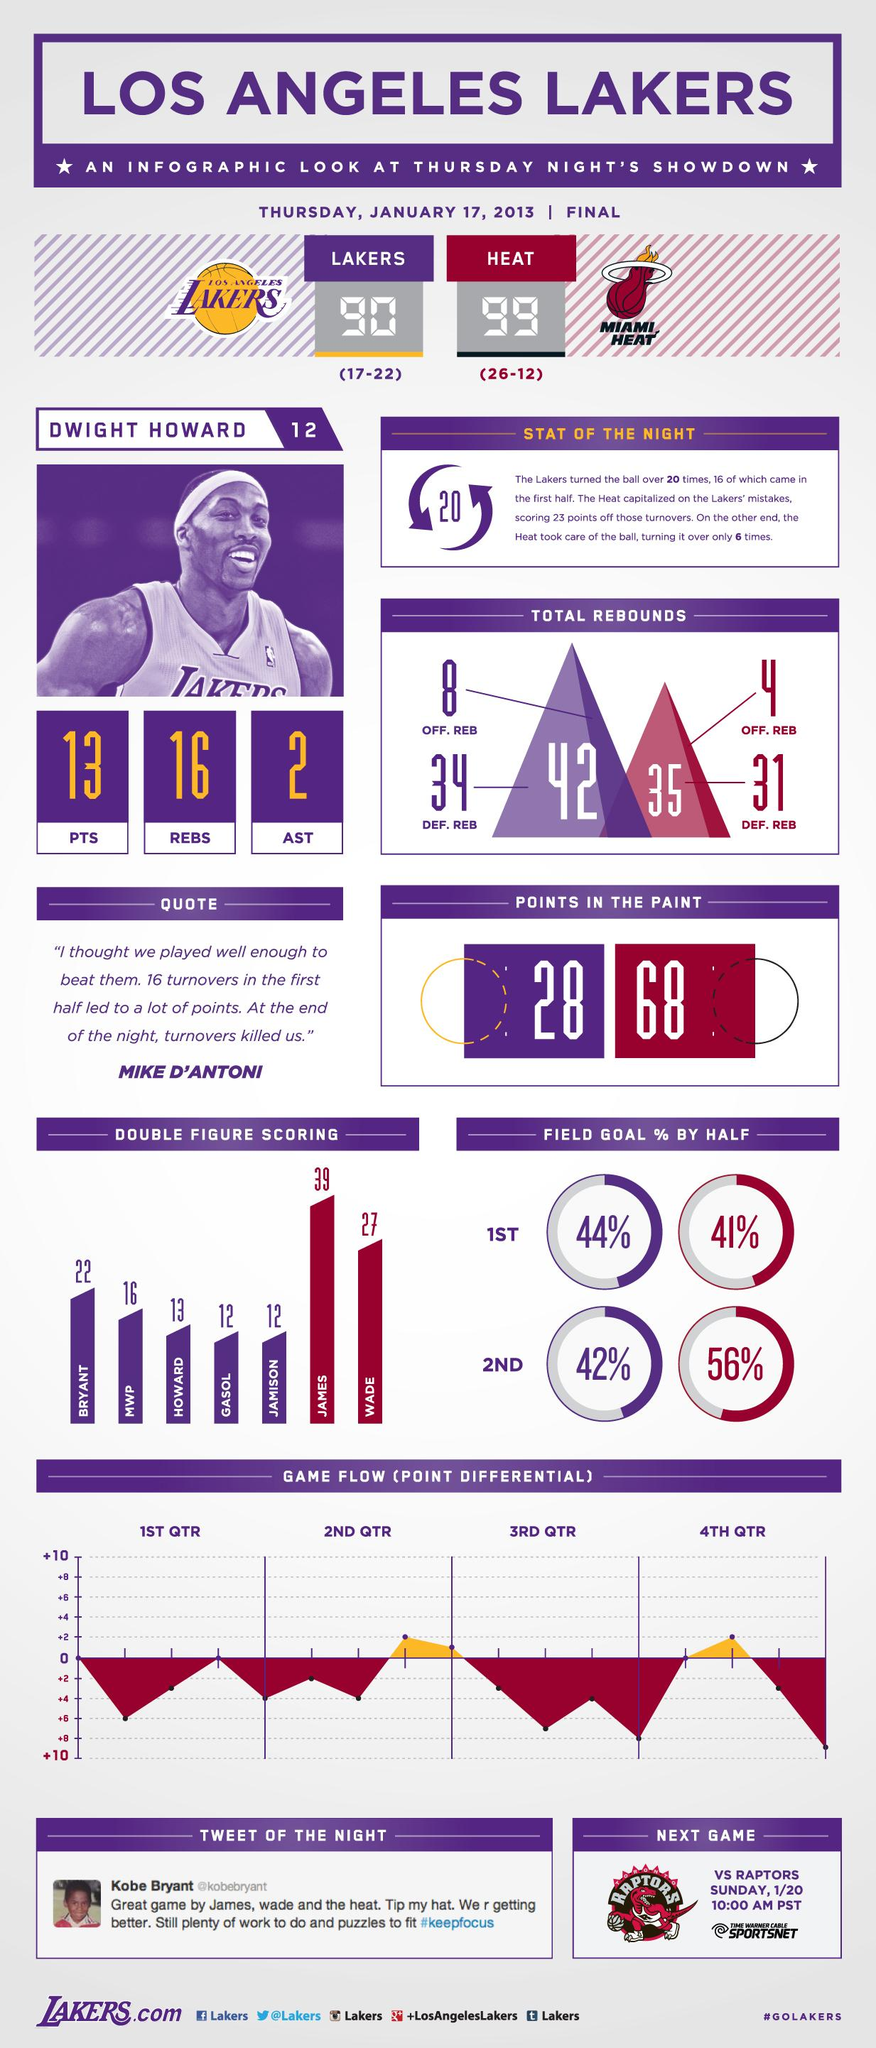Draw attention to some important aspects in this diagram. Dwight Howard has achieved 16 rebounds. The two names mentioned in the Miami Heat infographic are James and Wade. The combined scoring of James and Wade is 66. Off. REB stands for Offensive Rebounds. In the given sentence, the person is asking how many Offensive Rebounds (taken by players from the Lakers and Miami Heat teams) together amount to. The combined number of DEF and REB from the Los Angeles Lakers and Miami Heat is 65. 